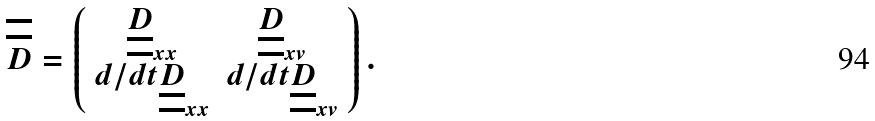Convert formula to latex. <formula><loc_0><loc_0><loc_500><loc_500>\overline { \overline { D } } = \left ( \begin{array} { c c } \underline { \underline { D } } _ { x x } & \underline { \underline { D } } _ { x v } \\ d / d t \underline { \underline { D } } _ { x x } & d / d t \underline { \underline { D } } _ { x v } \\ \end{array} \right ) .</formula> 